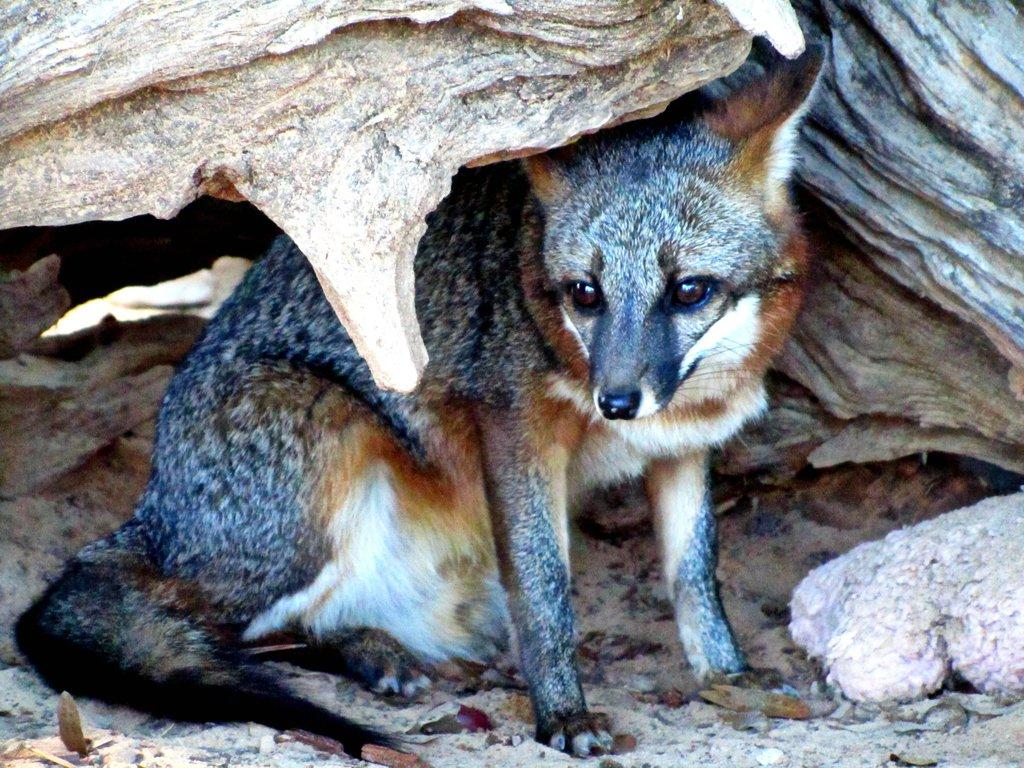What type of animal is in the image? There is an animal in the image, but its specific type cannot be determined from the provided facts. Can you describe the colors of the animal? The animal has brown, white, and cream colors. What can be seen in the background of the image? There is an object in the background of the image. What colors does the object in the background have? The object has brown and cream colors. How many police officers are sitting on the chairs in the image? There is no mention of chairs, police officers, or any related objects or individuals in the image. The image only contains an animal and an object in the background. 